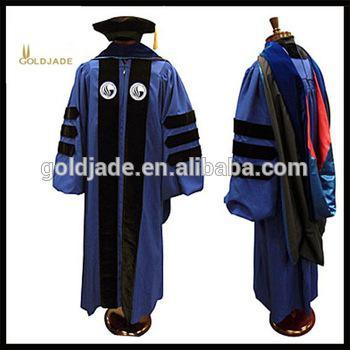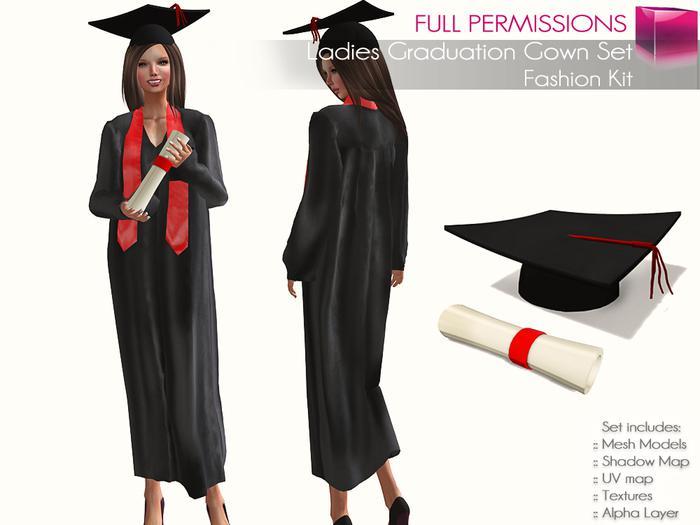The first image is the image on the left, the second image is the image on the right. Examine the images to the left and right. Is the description "There is a woman in the image on the right." accurate? Answer yes or no. Yes. 